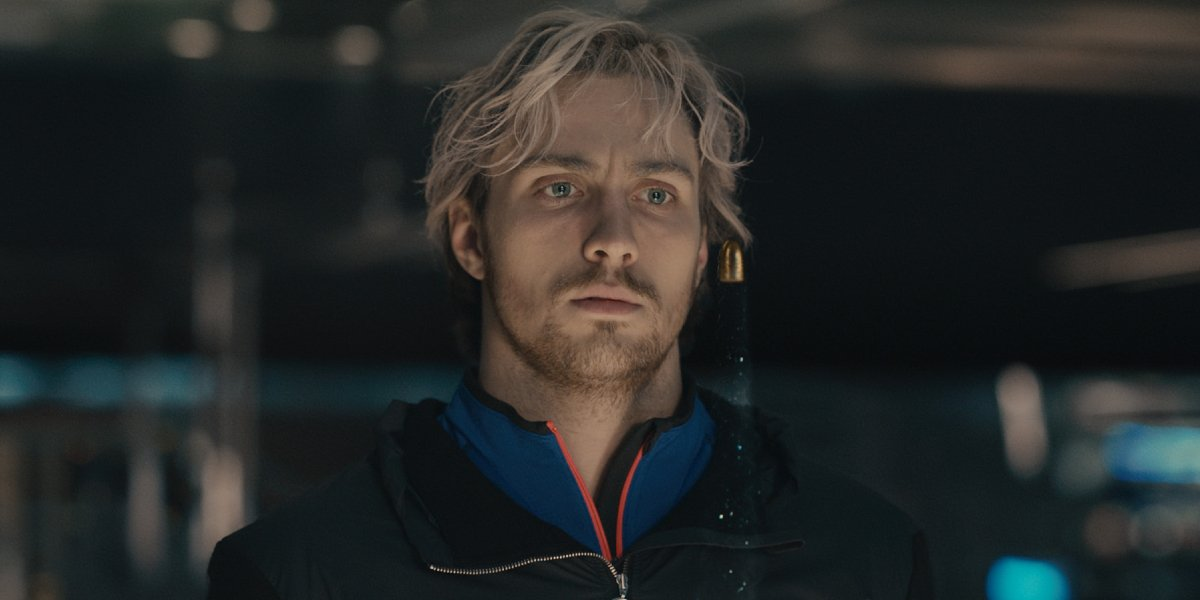Describe the scene in an extremely detailed manner. The image portrays a man standing alone in a dimly lit, possibly commercial environment. His shoulder-length blonde hair and beard give him a rugged appearance, while his blue and black jacket stands out as a vivid splash of color amid the otherwise subdued hues of the background. The soft glow of ambient light gently illuminates his serious face, casting subtle shadows that accentuate the intensity of his expression. Behind him, the background is blurred with indistinct shapes and muted colors, suggesting a bustling store or mall filled with people engaged in their activities. The man's focused gaze is directed off-frame, hinting at his deep thoughts or perhaps his anticipation of an off-screen event. The atmosphere of the image is one of quiet intensity, amplified by the interplay of light and shadow and the man's contemplative demeanor. 